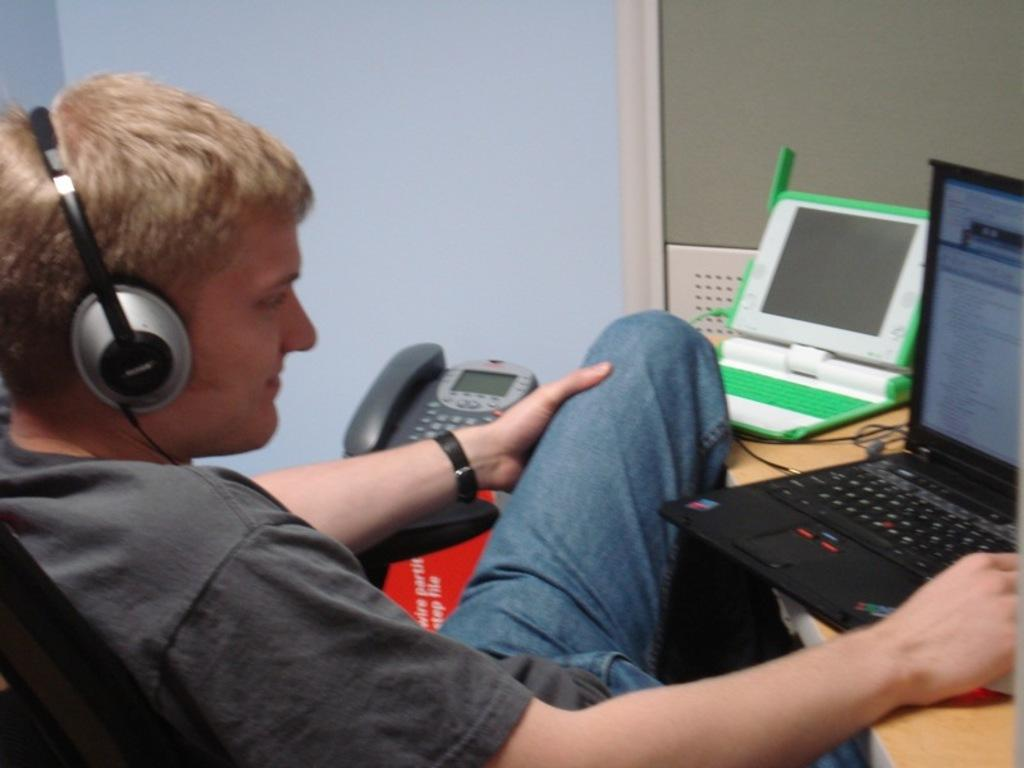Who is present in the image? There is a person in the image. What is the person wearing? The person is wearing headsets. Where is the person sitting in the image? The person is sitting in front of a table. What can be seen on the table? There are laptops and wires on the table. What is the background of the image? There is a wall visible in the image. What device is present in the image? There is a phone in the image. What is the person's income in the image? There is no information about the person's income in the image. What religion does the person practice in the image? There is no information about the person's religion in the image. 